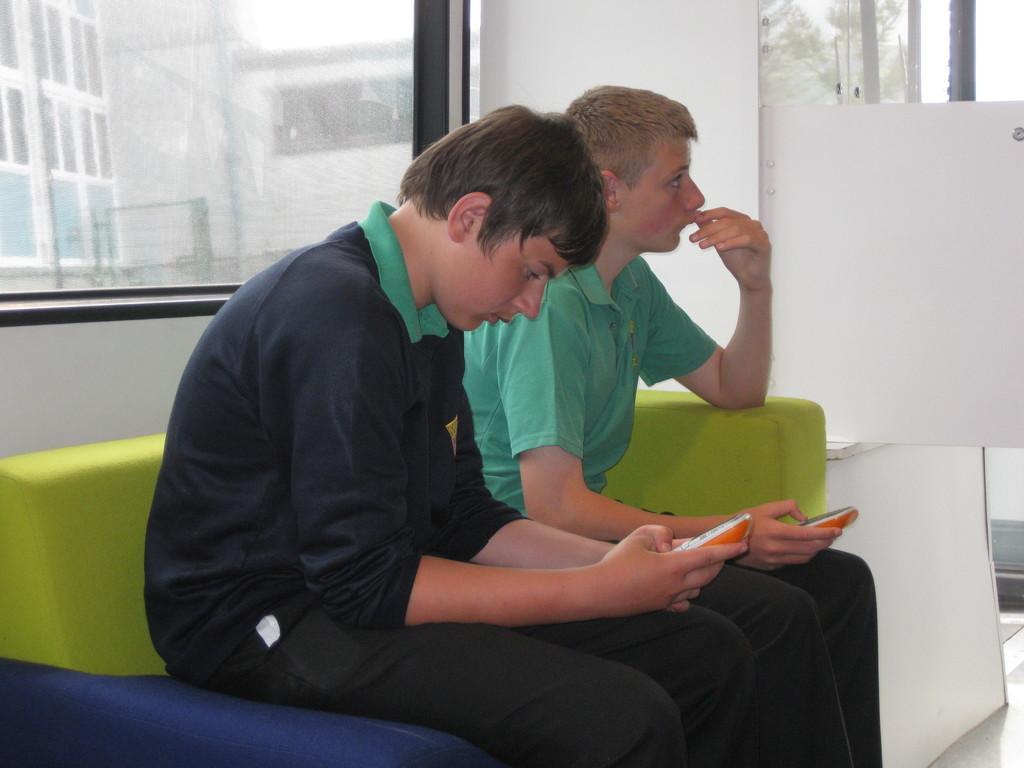Describe this image in one or two sentences. In this image,There are two people sitting on the sofa in the middle of the image and in the right side there is a white color board, in the background there is a glass window. 